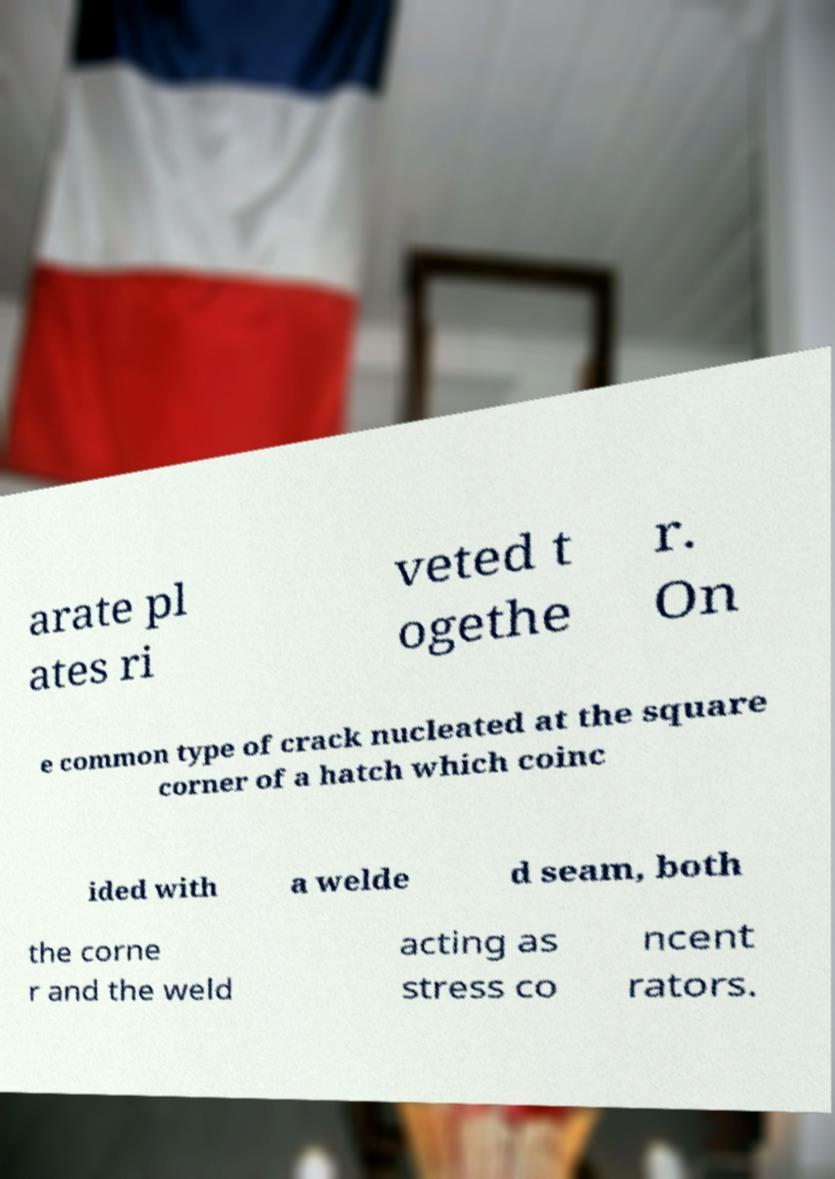For documentation purposes, I need the text within this image transcribed. Could you provide that? arate pl ates ri veted t ogethe r. On e common type of crack nucleated at the square corner of a hatch which coinc ided with a welde d seam, both the corne r and the weld acting as stress co ncent rators. 